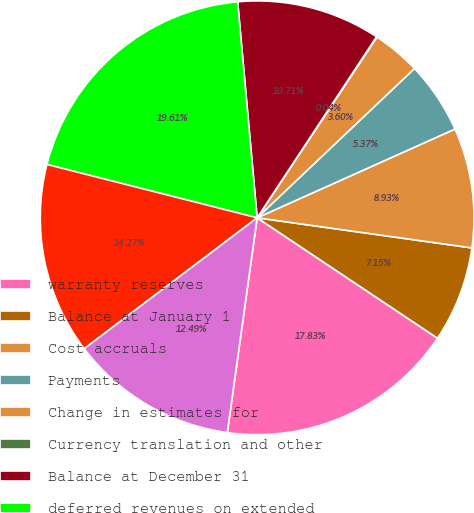Convert chart. <chart><loc_0><loc_0><loc_500><loc_500><pie_chart><fcel>warranty reserves<fcel>Balance at January 1<fcel>Cost accruals<fcel>Payments<fcel>Change in estimates for<fcel>Currency translation and other<fcel>Balance at December 31<fcel>deferred revenues on extended<fcel>Deferred revenues<fcel>Revenues recognized<nl><fcel>17.83%<fcel>7.15%<fcel>8.93%<fcel>5.37%<fcel>3.6%<fcel>0.04%<fcel>10.71%<fcel>19.61%<fcel>14.27%<fcel>12.49%<nl></chart> 